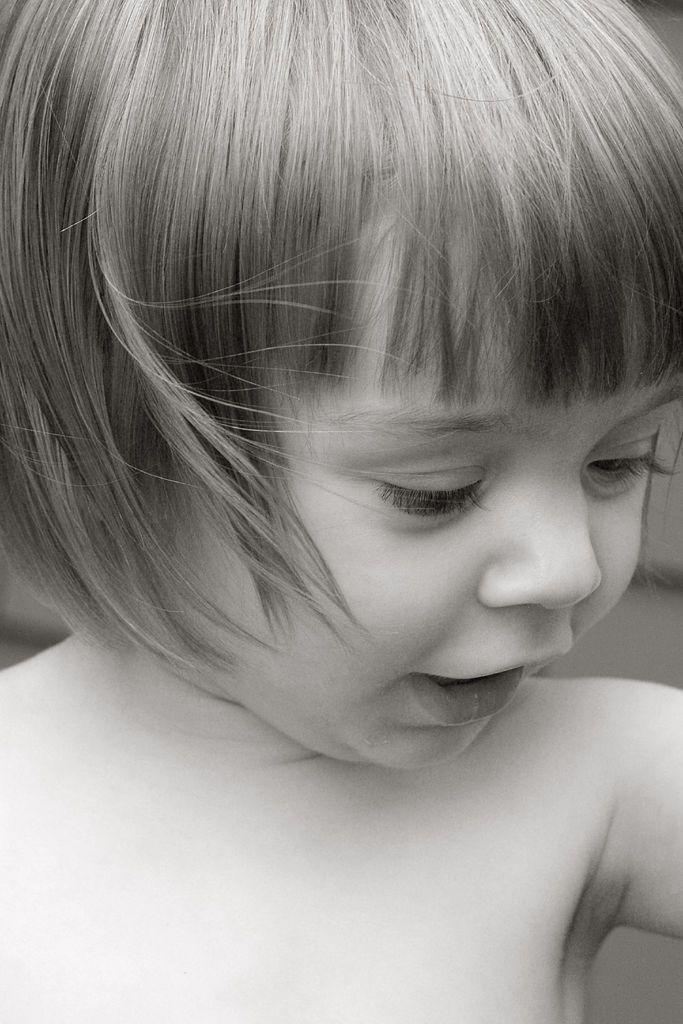Please provide a concise description of this image. A beautiful girl is talking, it is in black and white color. 